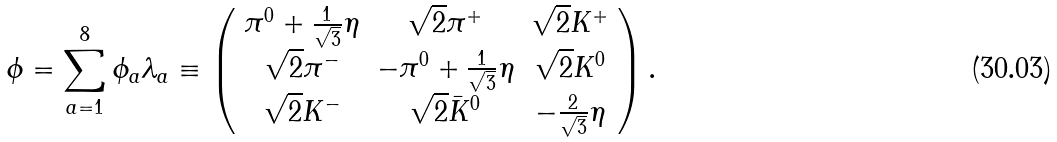Convert formula to latex. <formula><loc_0><loc_0><loc_500><loc_500>\phi = \sum _ { a = 1 } ^ { 8 } \phi _ { a } \lambda _ { a } \equiv \left ( \begin{array} { c c c } \pi ^ { 0 } + \frac { 1 } { \sqrt { 3 } } \eta & \sqrt { 2 } \pi ^ { + } & \sqrt { 2 } K ^ { + } \\ \sqrt { 2 } \pi ^ { - } & - \pi ^ { 0 } + \frac { 1 } { \sqrt { 3 } } \eta & \sqrt { 2 } K ^ { 0 } \\ \sqrt { 2 } K ^ { - } & \sqrt { 2 } \bar { K } ^ { 0 } & - \frac { 2 } { \sqrt { 3 } } \eta \end{array} \right ) .</formula> 